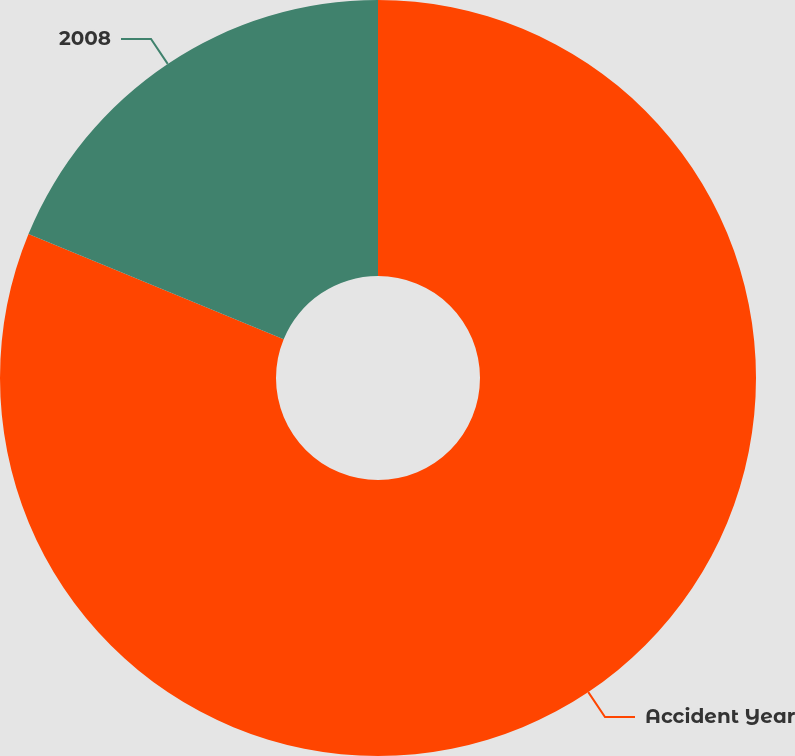Convert chart to OTSL. <chart><loc_0><loc_0><loc_500><loc_500><pie_chart><fcel>Accident Year<fcel>2008<nl><fcel>81.22%<fcel>18.78%<nl></chart> 